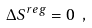<formula> <loc_0><loc_0><loc_500><loc_500>\Delta S ^ { r e g } = 0 \ ,</formula> 